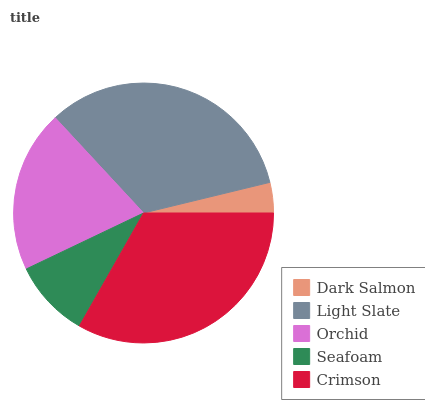Is Dark Salmon the minimum?
Answer yes or no. Yes. Is Crimson the maximum?
Answer yes or no. Yes. Is Light Slate the minimum?
Answer yes or no. No. Is Light Slate the maximum?
Answer yes or no. No. Is Light Slate greater than Dark Salmon?
Answer yes or no. Yes. Is Dark Salmon less than Light Slate?
Answer yes or no. Yes. Is Dark Salmon greater than Light Slate?
Answer yes or no. No. Is Light Slate less than Dark Salmon?
Answer yes or no. No. Is Orchid the high median?
Answer yes or no. Yes. Is Orchid the low median?
Answer yes or no. Yes. Is Light Slate the high median?
Answer yes or no. No. Is Seafoam the low median?
Answer yes or no. No. 